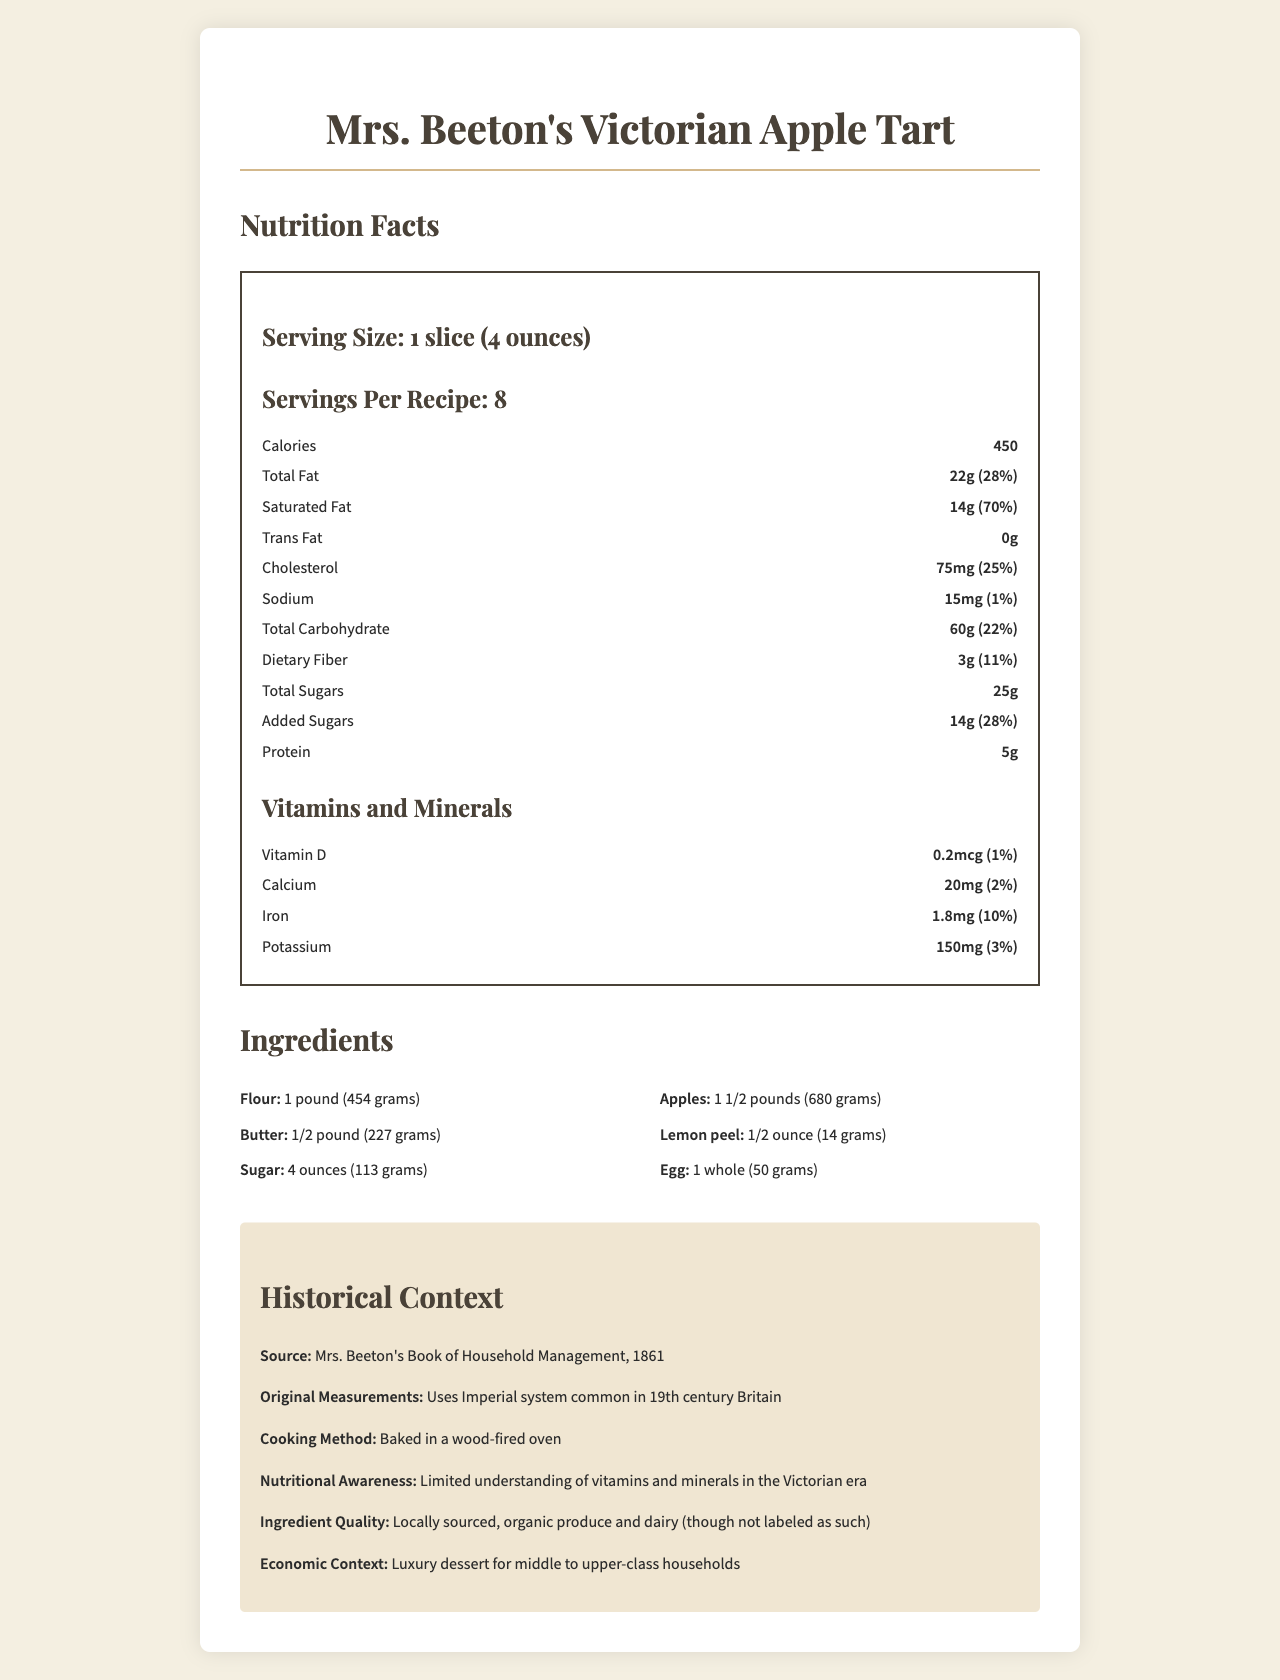what is the serving size for a slice of Mrs. Beeton's Victorian Apple Tart? This information is found at the beginning of the nutrition section under "Serving Size."
Answer: 1 slice (4 ounces) how many calories are in one serving of the apple tart? It is listed under the nutrition facts section as "Calories: 450."
Answer: 450 calories what is the amount of saturated fat per serving, and what percentage of the daily value does it represent? The nutrition facts section lists "Saturated Fat 14g (70%)."
Answer: 14g, 70% how many servings does the recipe make? This is stated under the "Servings Per Recipe" section.
Answer: 8 servings what is the total carbohydrate content per serving? The total carbohydrate amount is found in the nutrition label under "Total Carbohydrate."
Answer: 60g how much flour is used in the recipe, and what is its modern equivalent? The ingredient list shows "Flour: 1 pound (454 grams)."
Answer: 1 pound, 454 grams what is the main source of the recipe and its original context? The source and context are given in the historical context section.
Answer: Mrs. Beeton's Book of Household Management, 1861 what is the amount of protein per serving? A. 3g B. 5g C. 7g D. 9g The nutrition facts list "Protein: 5g."
Answer: B which vitamin has the lowest daily value percentage per serving, based on the document? A. Vitamin C B. Calcium C. Iron D. Vitamin D Vitamin D has a daily value of 1%, which is the lowest among the listed vitamins and minerals.
Answer: D how was the apple tart historically baked? This information can be found under the historical context section.
Answer: Baked in a wood-fired oven is there any trans fat in the apple tart? The nutrition facts state "Trans Fat: 0g."
Answer: No what can you summarize about the apple tart's nutritional information and historical context provided in the document? The summary captures all the key points from both the nutritional facts and the historical context sections.
Answer: Mrs. Beeton's Victorian Apple Tart is a dessert from 1861, made with traditional ingredients measured in imperial units. Each serving contains 450 calories, 22g of fat, 60g of carbohydrates, and 5g of protein. It also provides multiple vitamins and minerals with varying daily values. The tart was historically baked in a wood-fired oven and was considered a luxury dessert for middle to upper-class households. how does the daily value percentage of dietary fiber compare to that of added sugars? According to the nutrition facts, dietary fiber has a daily value of 11%, while added sugars have a daily value of 28%.
Answer: Dietary Fiber: 11%, Added Sugars: 28% what is the amount of potassium per serving? The amount of potassium per serving is listed in the vitamins and minerals section as "Potassium: 150mg (3%)."
Answer: 150mg what are the original measurements used in the recipe? This is indicated in the historical context section under "Original Measurements."
Answer: Uses Imperial system common in 19th century Britain how does the historical economic context describe who could afford this dessert? The economic context provided in the historical context section states that it was a luxury dessert for middle to upper-class households.
Answer: Luxury dessert for middle to upper-class households what would the total amount of sugar, including added sugars, be in all servings combined? The document states the amount of total sugars per serving (25g) and added sugars per serving (14g), but it does not provide the information needed to determine the total amount of sugar for all servings combined.
Answer: Cannot be determined 